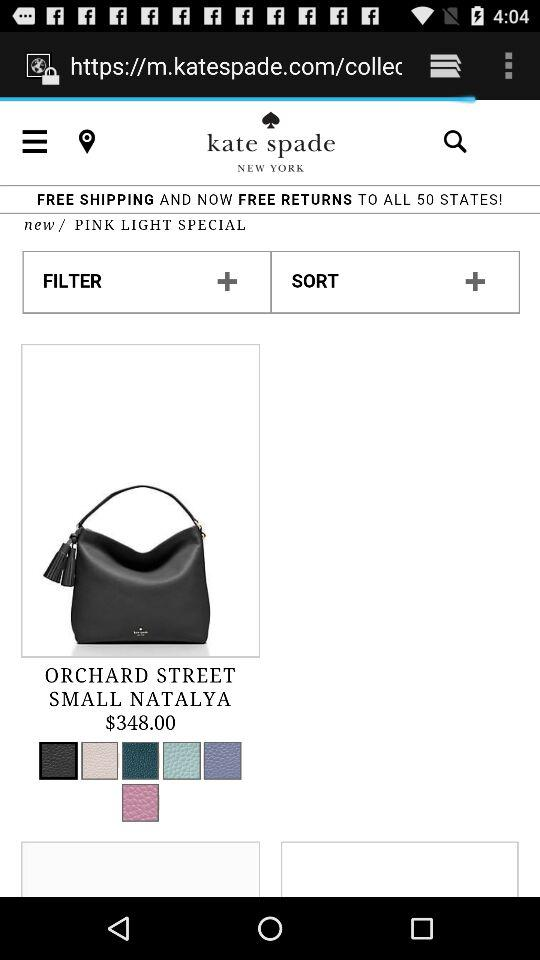What are the shipping charges? It is free of cost. 